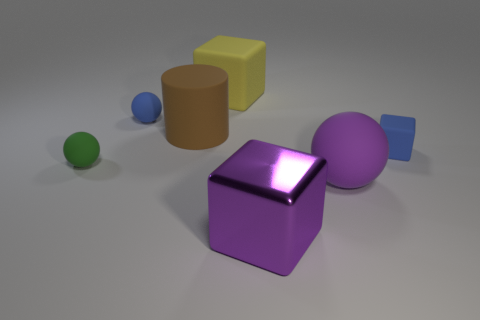Subtract all tiny matte cubes. How many cubes are left? 2 Add 2 large shiny objects. How many objects exist? 9 Subtract all purple blocks. How many blocks are left? 2 Subtract all cubes. How many objects are left? 4 Add 4 purple rubber objects. How many purple rubber objects are left? 5 Add 5 big purple blocks. How many big purple blocks exist? 6 Subtract 0 red blocks. How many objects are left? 7 Subtract 3 blocks. How many blocks are left? 0 Subtract all blue cylinders. Subtract all cyan blocks. How many cylinders are left? 1 Subtract all big purple rubber balls. Subtract all big yellow rubber things. How many objects are left? 5 